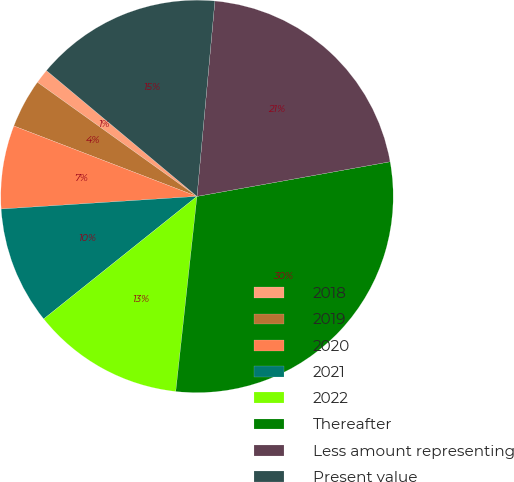Convert chart. <chart><loc_0><loc_0><loc_500><loc_500><pie_chart><fcel>2018<fcel>2019<fcel>2020<fcel>2021<fcel>2022<fcel>Thereafter<fcel>Less amount representing<fcel>Present value<nl><fcel>1.2%<fcel>4.04%<fcel>6.87%<fcel>9.71%<fcel>12.54%<fcel>29.55%<fcel>20.72%<fcel>15.37%<nl></chart> 